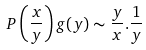<formula> <loc_0><loc_0><loc_500><loc_500>P \left ( \frac { x } { y } \right ) g ( y ) \sim \frac { y } { x } . \frac { 1 } { y }</formula> 